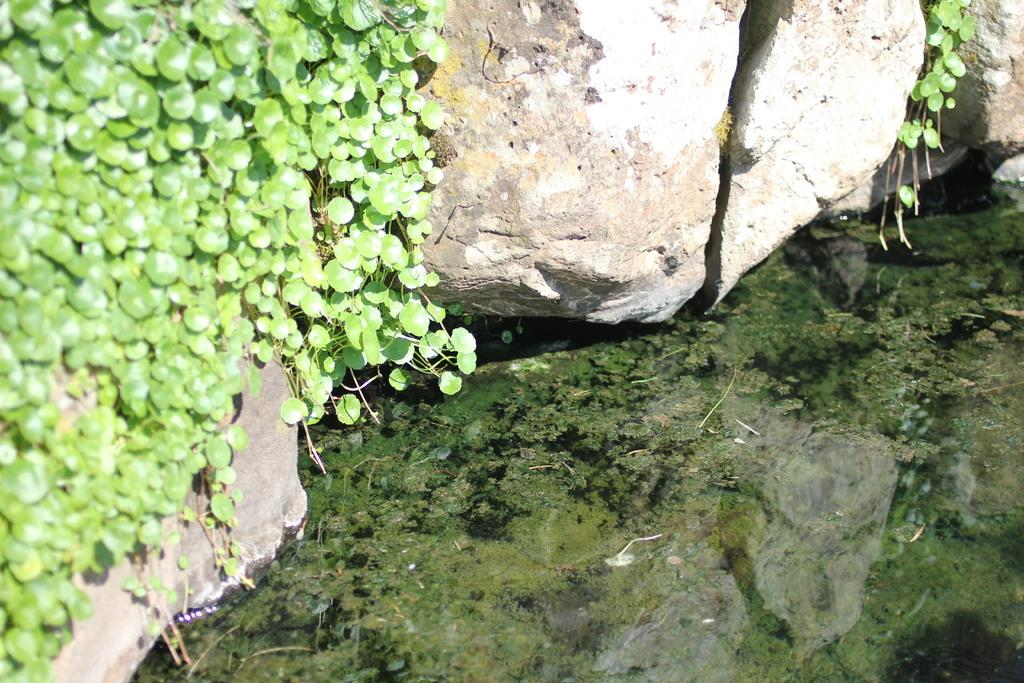What is the primary element visible in the image? There is water in the image. What type of living organisms can be seen in the image? Plants are visible in the image. What other objects can be seen in the image? There are stones in the image. What type of needle is being used to sew the glove in the image? There is no needle or glove present in the image; it features water, plants, and stones. 